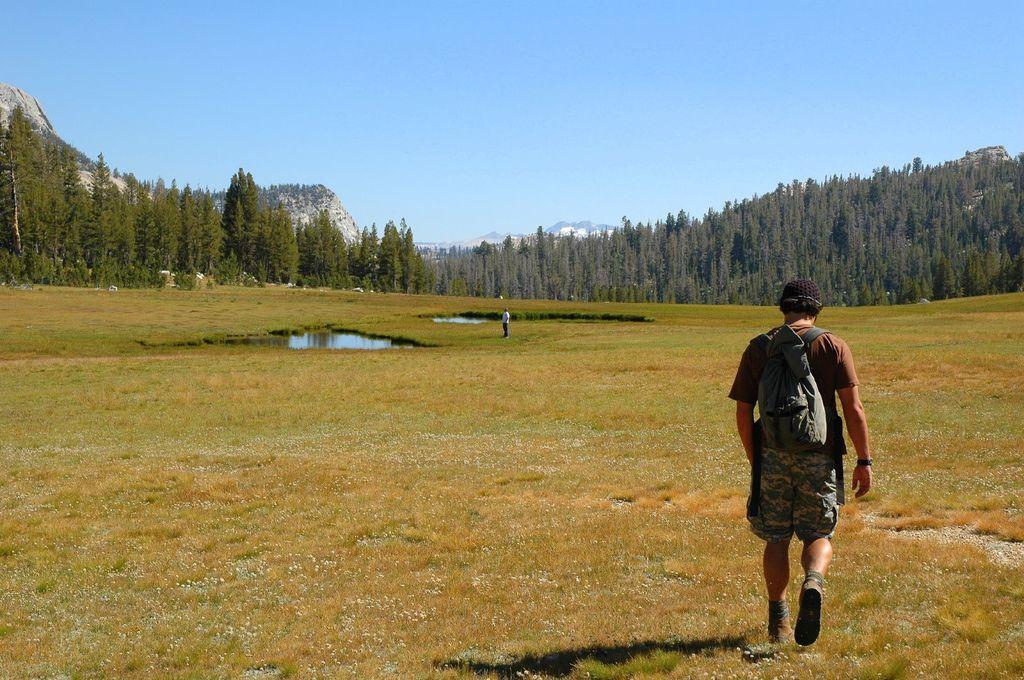Please provide a concise description of this image. In the foreground of the picture we can see grass, water bodies and two persons. In the middle of the picture there are mountains and trees. At the top it is sky. 